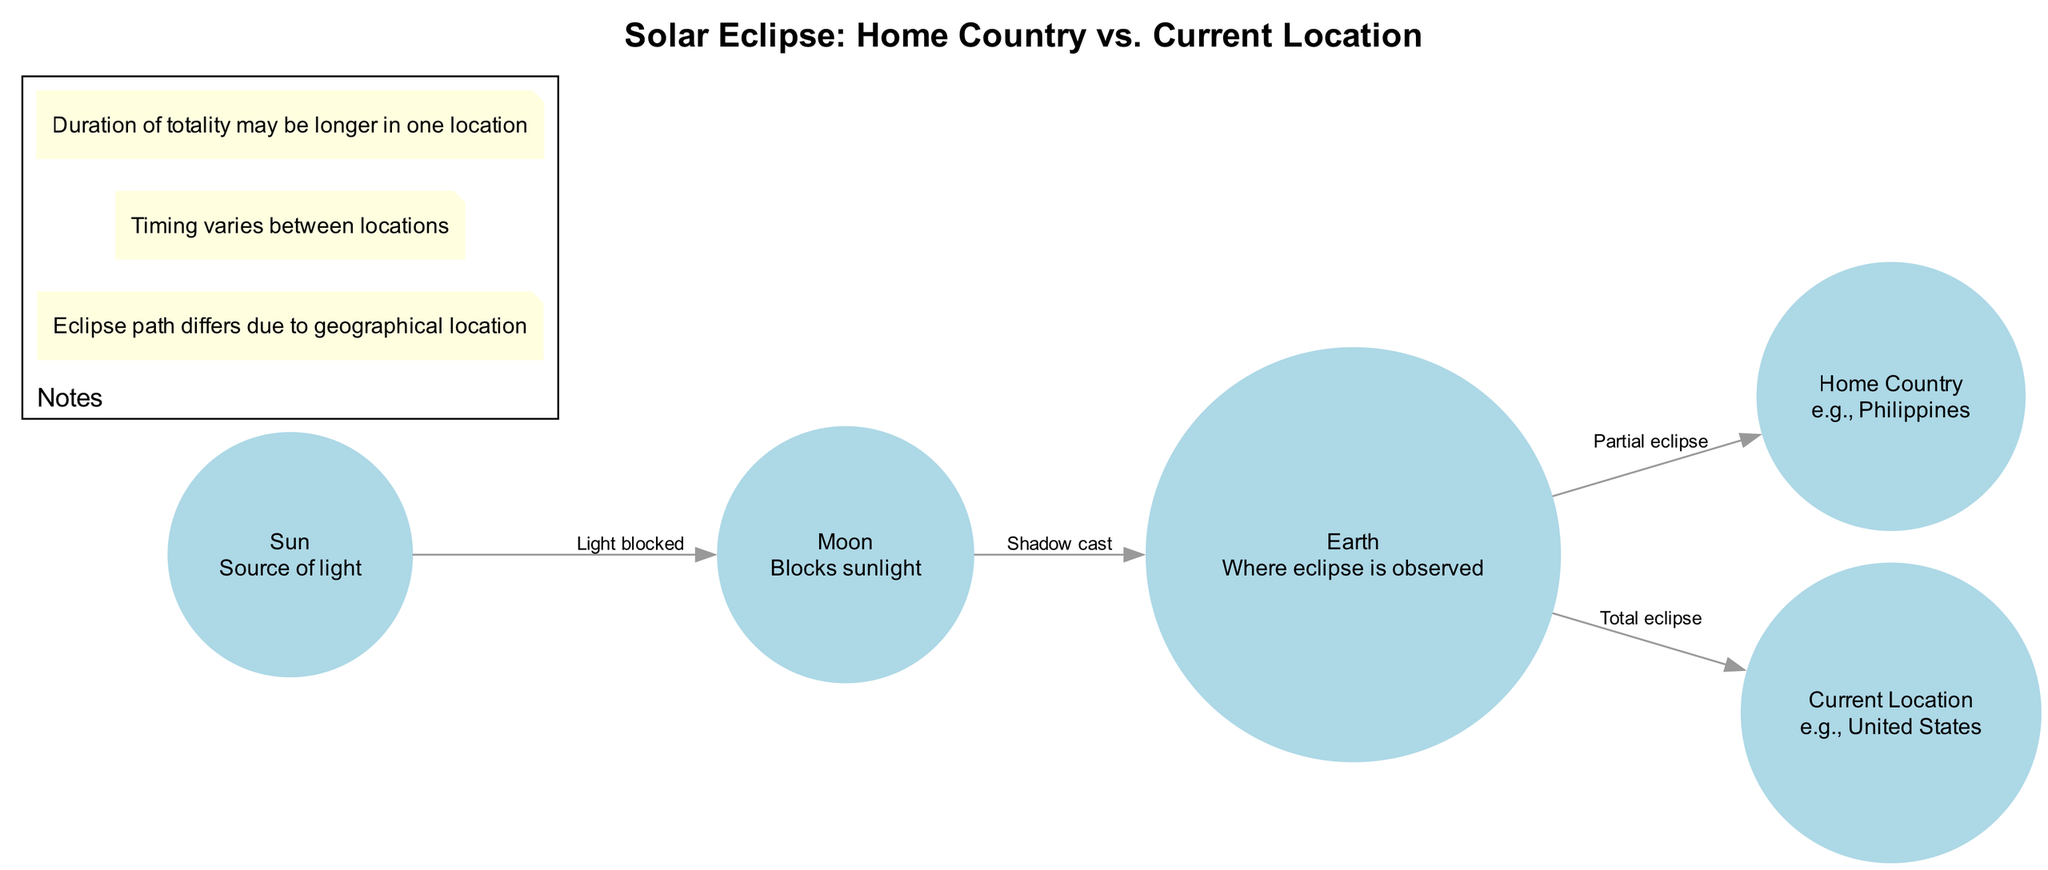What is the source of light in the diagram? The diagram identifies the "Sun" as the source of light, which is explicitly noted in the node descriptions.
Answer: Sun Which celestial body blocks sunlight? According to the diagram, the "Moon" is labeled as the body that blocks sunlight, indicated by the connecting edge to the Sun.
Answer: Moon How many locations are depicted in the diagram? The diagram features two specific locations: "Home Country" and "Current Location." Counting these nodes gives a total of two locations.
Answer: 2 What type of eclipse is observed in the home country? The diagram states that the observer in the "Home Country" views a "Partial eclipse," as denoted by the edge connecting Earth to Home Country.
Answer: Partial eclipse What type of eclipse is observed in the current location? The edge connecting Earth to Current Location indicates that a "Total eclipse" is observed in the Current Location, which is specified in the diagram.
Answer: Total eclipse How does the eclipse path differ between locations? The diagram notes in the "Notes" section that "Eclipse path differs due to geographical location," highlighting how the visibility of the eclipse changes based on where it is observed.
Answer: Geographical location What factor varies between the home country and current location regarding the timing of the eclipse? The "Notes" section specifically mentions that "Timing varies between locations," indicating that different locations experience the eclipse at different times.
Answer: Timing What is indicated by the edge labeled "Shadow cast"? The label "Shadow cast" describes the relationship between the Moon and the Earth, indicating that the Moon blocks sunlight and casts a shadow on the Earth during an eclipse.
Answer: Shadow cast How is the duration of totality described in the diagram? The "Notes" section states that "Duration of totality may be longer in one location," suggesting that this can vary between the home country and current location.
Answer: Longer in one location 